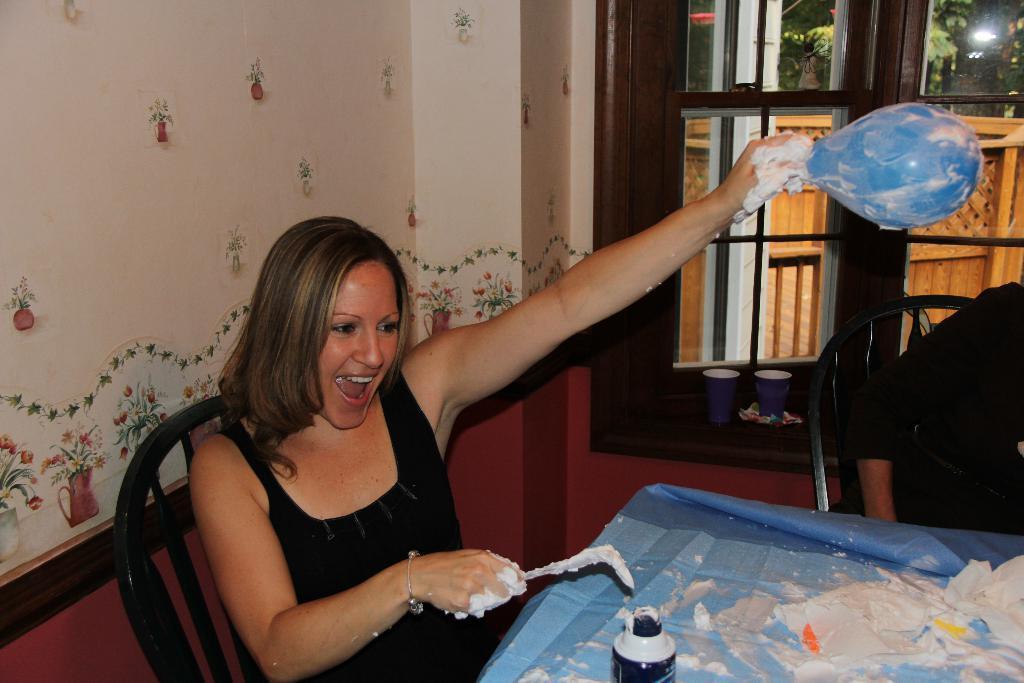Can you describe this image briefly? On the background we can see a window and a decorative wall. Here we can se one women sitting on a chair and she is holding a balloon in her hand and on the table we can see a bottle. 